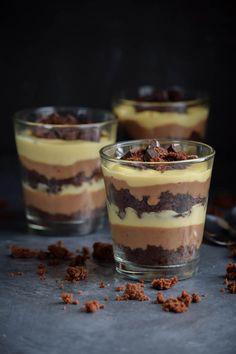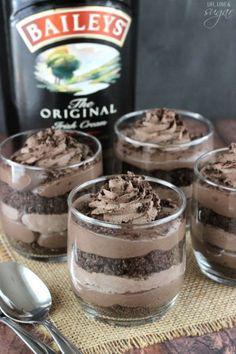The first image is the image on the left, the second image is the image on the right. Given the left and right images, does the statement "There are three cups of dessert in the image on the left." hold true? Answer yes or no. Yes. The first image is the image on the left, the second image is the image on the right. Given the left and right images, does the statement "An image shows a group of layered desserts topped with brown whipped cream and sprinkles." hold true? Answer yes or no. Yes. 